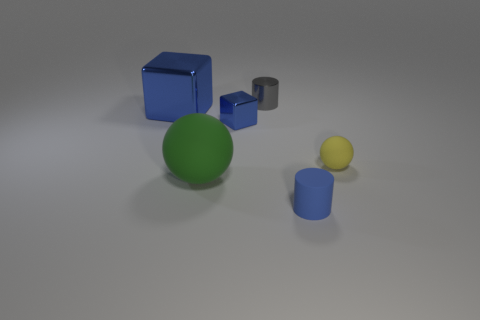Is the tiny blue cube made of the same material as the tiny yellow ball?
Give a very brief answer. No. What is the shape of the large thing that is in front of the blue object that is to the left of the rubber sphere that is in front of the yellow sphere?
Offer a very short reply. Sphere. There is a thing that is behind the big green object and on the left side of the small blue block; what material is it?
Your answer should be very brief. Metal. What is the color of the matte object on the right side of the cylinder that is in front of the rubber ball that is left of the yellow sphere?
Keep it short and to the point. Yellow. What number of blue objects are metallic things or metallic balls?
Your answer should be compact. 2. What number of other things are there of the same size as the green rubber thing?
Offer a very short reply. 1. What number of big purple metal blocks are there?
Your answer should be very brief. 0. Is there any other thing that has the same shape as the tiny yellow matte thing?
Offer a very short reply. Yes. Does the small cylinder in front of the tiny gray cylinder have the same material as the tiny cylinder behind the small blue cylinder?
Provide a short and direct response. No. What is the tiny sphere made of?
Keep it short and to the point. Rubber. 